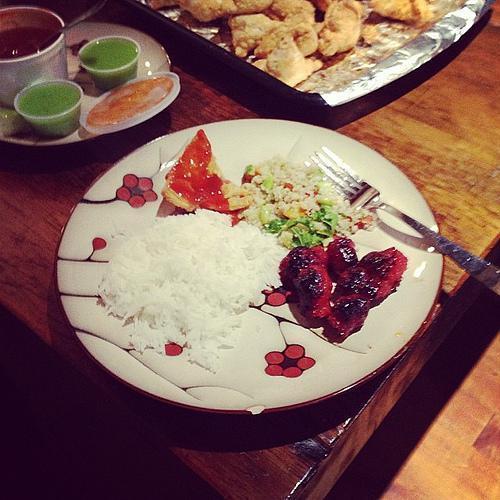How many fork on the plate?
Give a very brief answer. 1. 